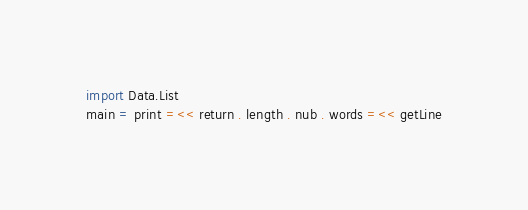Convert code to text. <code><loc_0><loc_0><loc_500><loc_500><_Haskell_>import Data.List
main = print =<< return . length . nub . words =<< getLine
</code> 